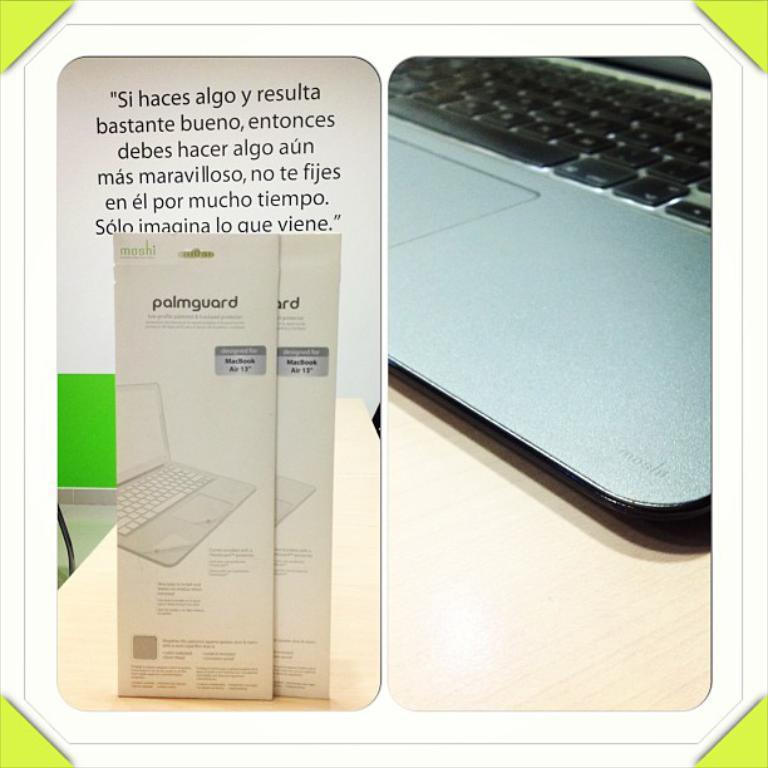<image>
Provide a brief description of the given image. Two Palmguard products for the MacBook Air are on a desk. 